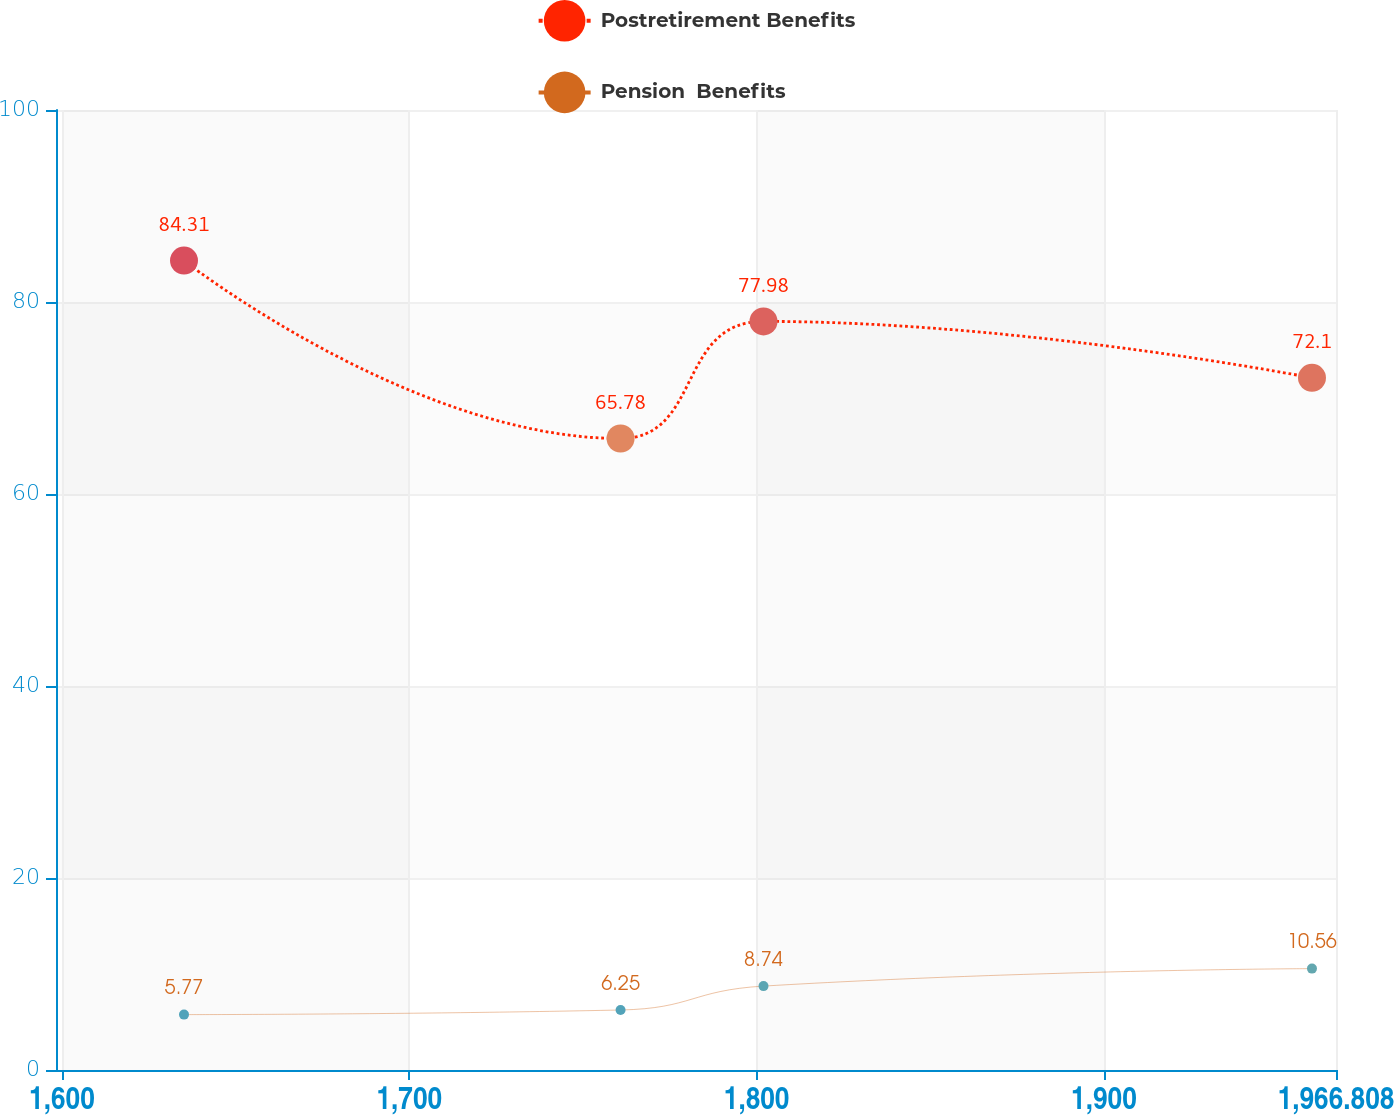Convert chart to OTSL. <chart><loc_0><loc_0><loc_500><loc_500><line_chart><ecel><fcel>Postretirement Benefits<fcel>Pension  Benefits<nl><fcel>1635.14<fcel>84.31<fcel>5.77<nl><fcel>1760.83<fcel>65.78<fcel>6.25<nl><fcel>1801.98<fcel>77.98<fcel>8.74<nl><fcel>1959.89<fcel>72.1<fcel>10.56<nl><fcel>2003.66<fcel>76.13<fcel>8.09<nl></chart> 